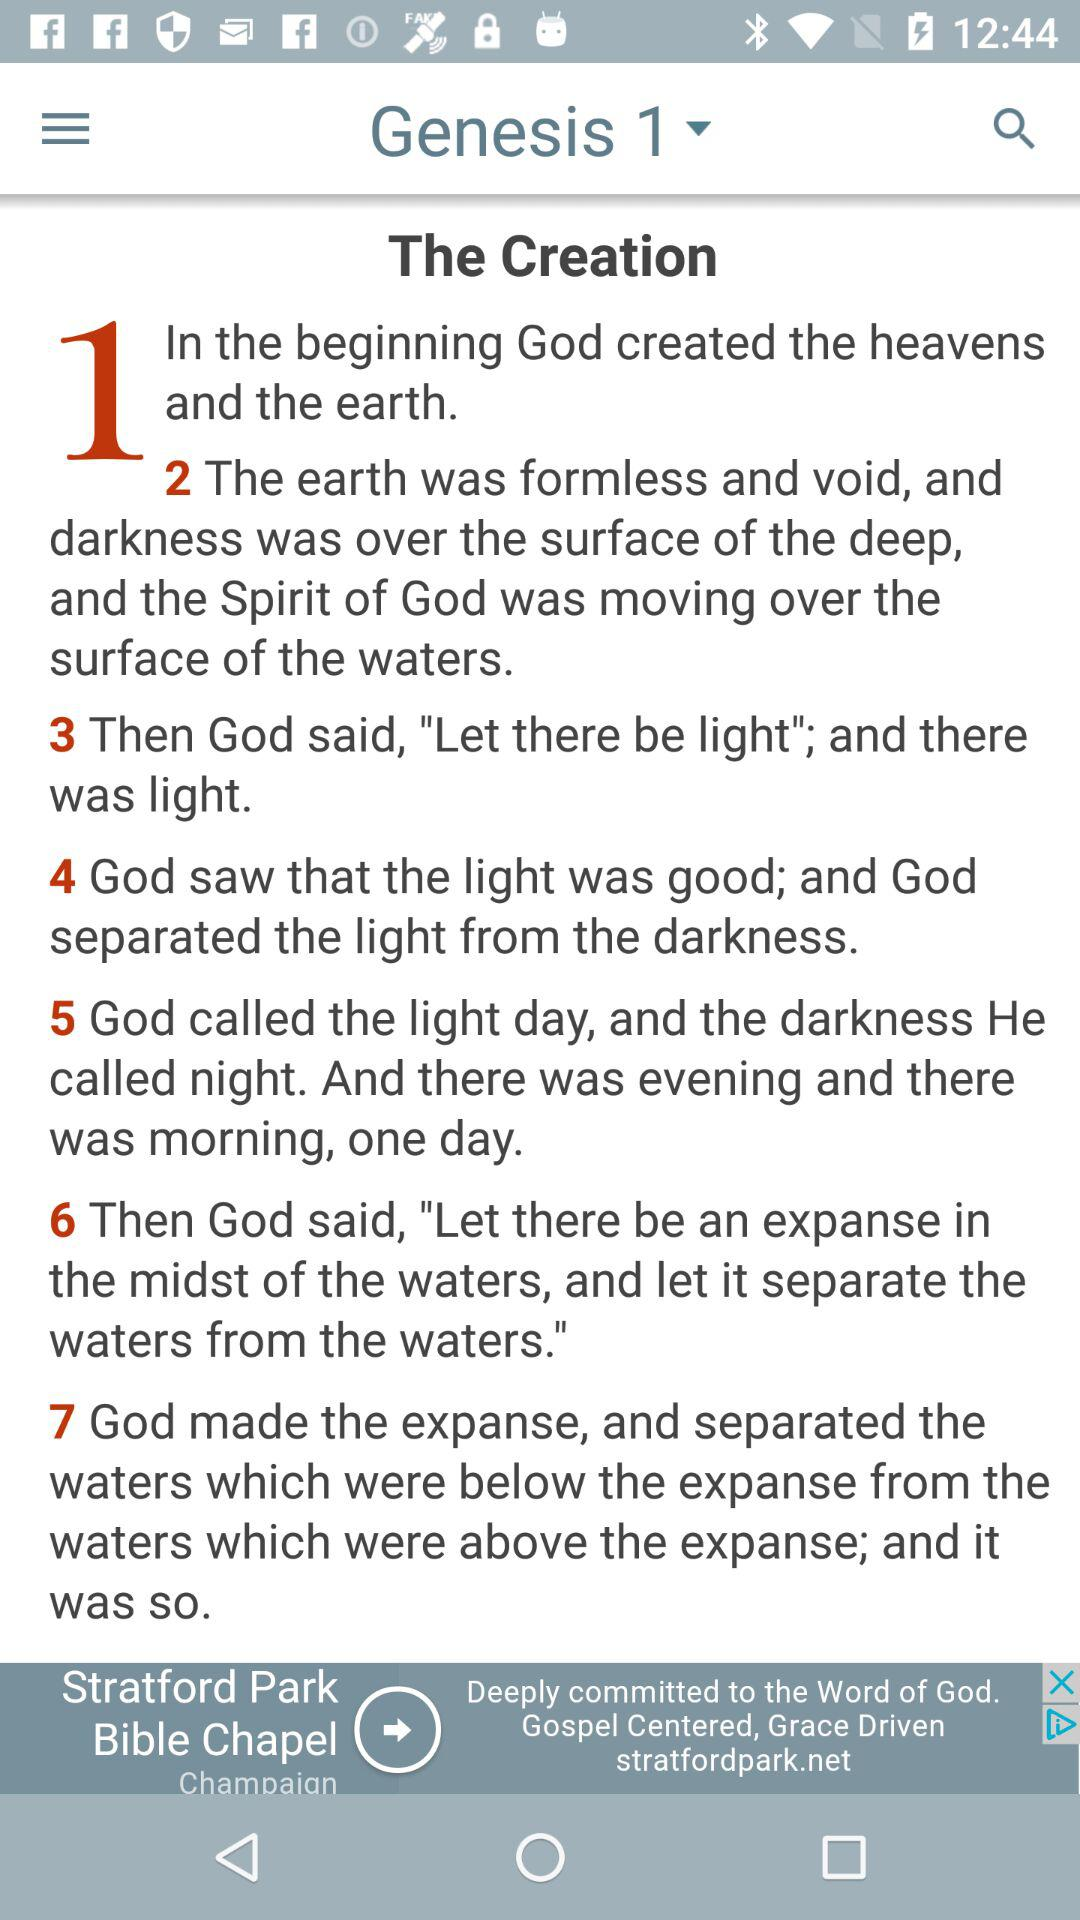How many verses are there in Genesis 1?
Answer the question using a single word or phrase. 7 